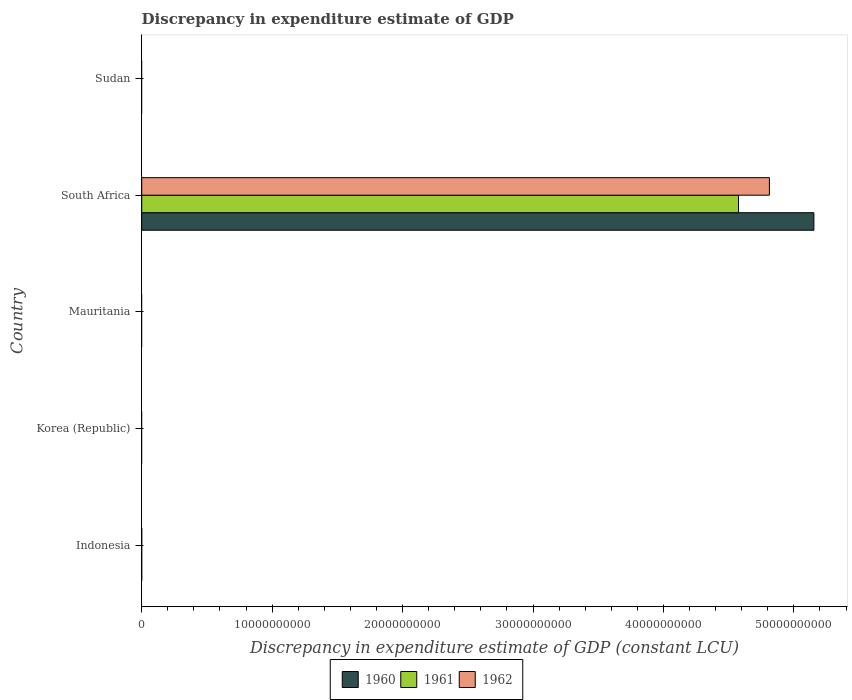Are the number of bars per tick equal to the number of legend labels?
Give a very brief answer. No. How many bars are there on the 5th tick from the bottom?
Give a very brief answer. 0. What is the label of the 1st group of bars from the top?
Your answer should be compact. Sudan. What is the discrepancy in expenditure estimate of GDP in 1961 in Korea (Republic)?
Keep it short and to the point. 0. Across all countries, what is the maximum discrepancy in expenditure estimate of GDP in 1961?
Your response must be concise. 4.58e+1. In which country was the discrepancy in expenditure estimate of GDP in 1960 maximum?
Your answer should be very brief. South Africa. What is the total discrepancy in expenditure estimate of GDP in 1962 in the graph?
Your answer should be very brief. 4.81e+1. What is the average discrepancy in expenditure estimate of GDP in 1961 per country?
Make the answer very short. 9.15e+09. What is the difference between the discrepancy in expenditure estimate of GDP in 1961 and discrepancy in expenditure estimate of GDP in 1960 in South Africa?
Make the answer very short. -5.78e+09. In how many countries, is the discrepancy in expenditure estimate of GDP in 1960 greater than 2000000000 LCU?
Give a very brief answer. 1. What is the difference between the highest and the lowest discrepancy in expenditure estimate of GDP in 1960?
Your answer should be compact. 5.15e+1. How many bars are there?
Keep it short and to the point. 3. How many countries are there in the graph?
Your answer should be compact. 5. Are the values on the major ticks of X-axis written in scientific E-notation?
Make the answer very short. No. Does the graph contain any zero values?
Offer a terse response. Yes. Does the graph contain grids?
Your answer should be compact. No. How many legend labels are there?
Your answer should be very brief. 3. What is the title of the graph?
Your response must be concise. Discrepancy in expenditure estimate of GDP. Does "1998" appear as one of the legend labels in the graph?
Make the answer very short. No. What is the label or title of the X-axis?
Provide a short and direct response. Discrepancy in expenditure estimate of GDP (constant LCU). What is the label or title of the Y-axis?
Make the answer very short. Country. What is the Discrepancy in expenditure estimate of GDP (constant LCU) in 1960 in Indonesia?
Offer a terse response. 0. What is the Discrepancy in expenditure estimate of GDP (constant LCU) in 1962 in Indonesia?
Ensure brevity in your answer.  0. What is the Discrepancy in expenditure estimate of GDP (constant LCU) of 1960 in Mauritania?
Provide a succinct answer. 0. What is the Discrepancy in expenditure estimate of GDP (constant LCU) of 1962 in Mauritania?
Provide a succinct answer. 0. What is the Discrepancy in expenditure estimate of GDP (constant LCU) in 1960 in South Africa?
Your answer should be compact. 5.15e+1. What is the Discrepancy in expenditure estimate of GDP (constant LCU) of 1961 in South Africa?
Your answer should be very brief. 4.58e+1. What is the Discrepancy in expenditure estimate of GDP (constant LCU) in 1962 in South Africa?
Your answer should be compact. 4.81e+1. What is the Discrepancy in expenditure estimate of GDP (constant LCU) in 1962 in Sudan?
Provide a succinct answer. 0. Across all countries, what is the maximum Discrepancy in expenditure estimate of GDP (constant LCU) in 1960?
Make the answer very short. 5.15e+1. Across all countries, what is the maximum Discrepancy in expenditure estimate of GDP (constant LCU) in 1961?
Your answer should be compact. 4.58e+1. Across all countries, what is the maximum Discrepancy in expenditure estimate of GDP (constant LCU) in 1962?
Offer a terse response. 4.81e+1. What is the total Discrepancy in expenditure estimate of GDP (constant LCU) of 1960 in the graph?
Keep it short and to the point. 5.15e+1. What is the total Discrepancy in expenditure estimate of GDP (constant LCU) in 1961 in the graph?
Offer a very short reply. 4.58e+1. What is the total Discrepancy in expenditure estimate of GDP (constant LCU) of 1962 in the graph?
Your answer should be very brief. 4.81e+1. What is the average Discrepancy in expenditure estimate of GDP (constant LCU) in 1960 per country?
Offer a terse response. 1.03e+1. What is the average Discrepancy in expenditure estimate of GDP (constant LCU) in 1961 per country?
Offer a terse response. 9.15e+09. What is the average Discrepancy in expenditure estimate of GDP (constant LCU) of 1962 per country?
Your answer should be compact. 9.62e+09. What is the difference between the Discrepancy in expenditure estimate of GDP (constant LCU) of 1960 and Discrepancy in expenditure estimate of GDP (constant LCU) of 1961 in South Africa?
Give a very brief answer. 5.78e+09. What is the difference between the Discrepancy in expenditure estimate of GDP (constant LCU) in 1960 and Discrepancy in expenditure estimate of GDP (constant LCU) in 1962 in South Africa?
Provide a short and direct response. 3.41e+09. What is the difference between the Discrepancy in expenditure estimate of GDP (constant LCU) of 1961 and Discrepancy in expenditure estimate of GDP (constant LCU) of 1962 in South Africa?
Offer a terse response. -2.37e+09. What is the difference between the highest and the lowest Discrepancy in expenditure estimate of GDP (constant LCU) of 1960?
Provide a succinct answer. 5.15e+1. What is the difference between the highest and the lowest Discrepancy in expenditure estimate of GDP (constant LCU) in 1961?
Give a very brief answer. 4.58e+1. What is the difference between the highest and the lowest Discrepancy in expenditure estimate of GDP (constant LCU) of 1962?
Make the answer very short. 4.81e+1. 